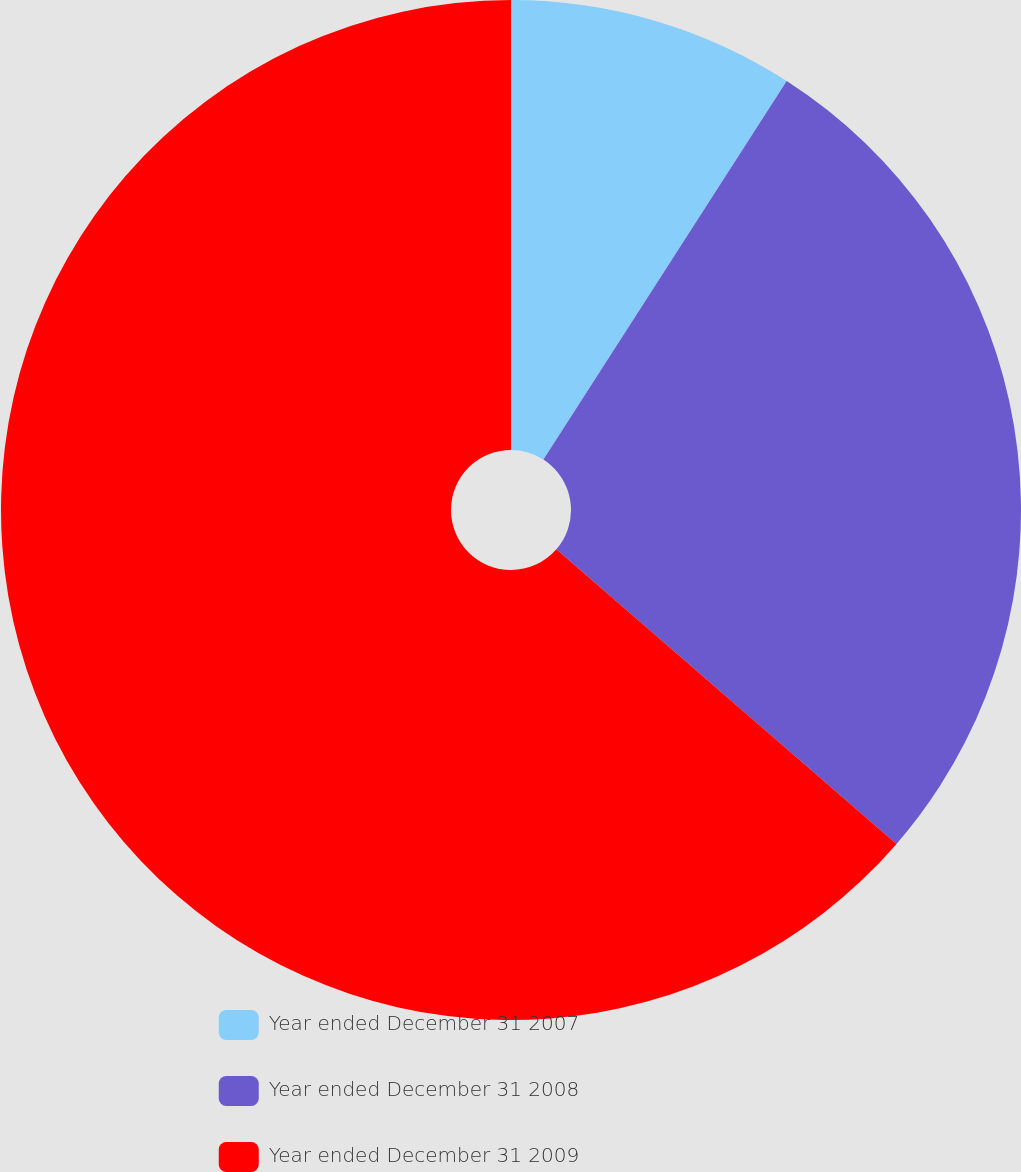Convert chart. <chart><loc_0><loc_0><loc_500><loc_500><pie_chart><fcel>Year ended December 31 2007<fcel>Year ended December 31 2008<fcel>Year ended December 31 2009<nl><fcel>9.09%<fcel>27.27%<fcel>63.64%<nl></chart> 